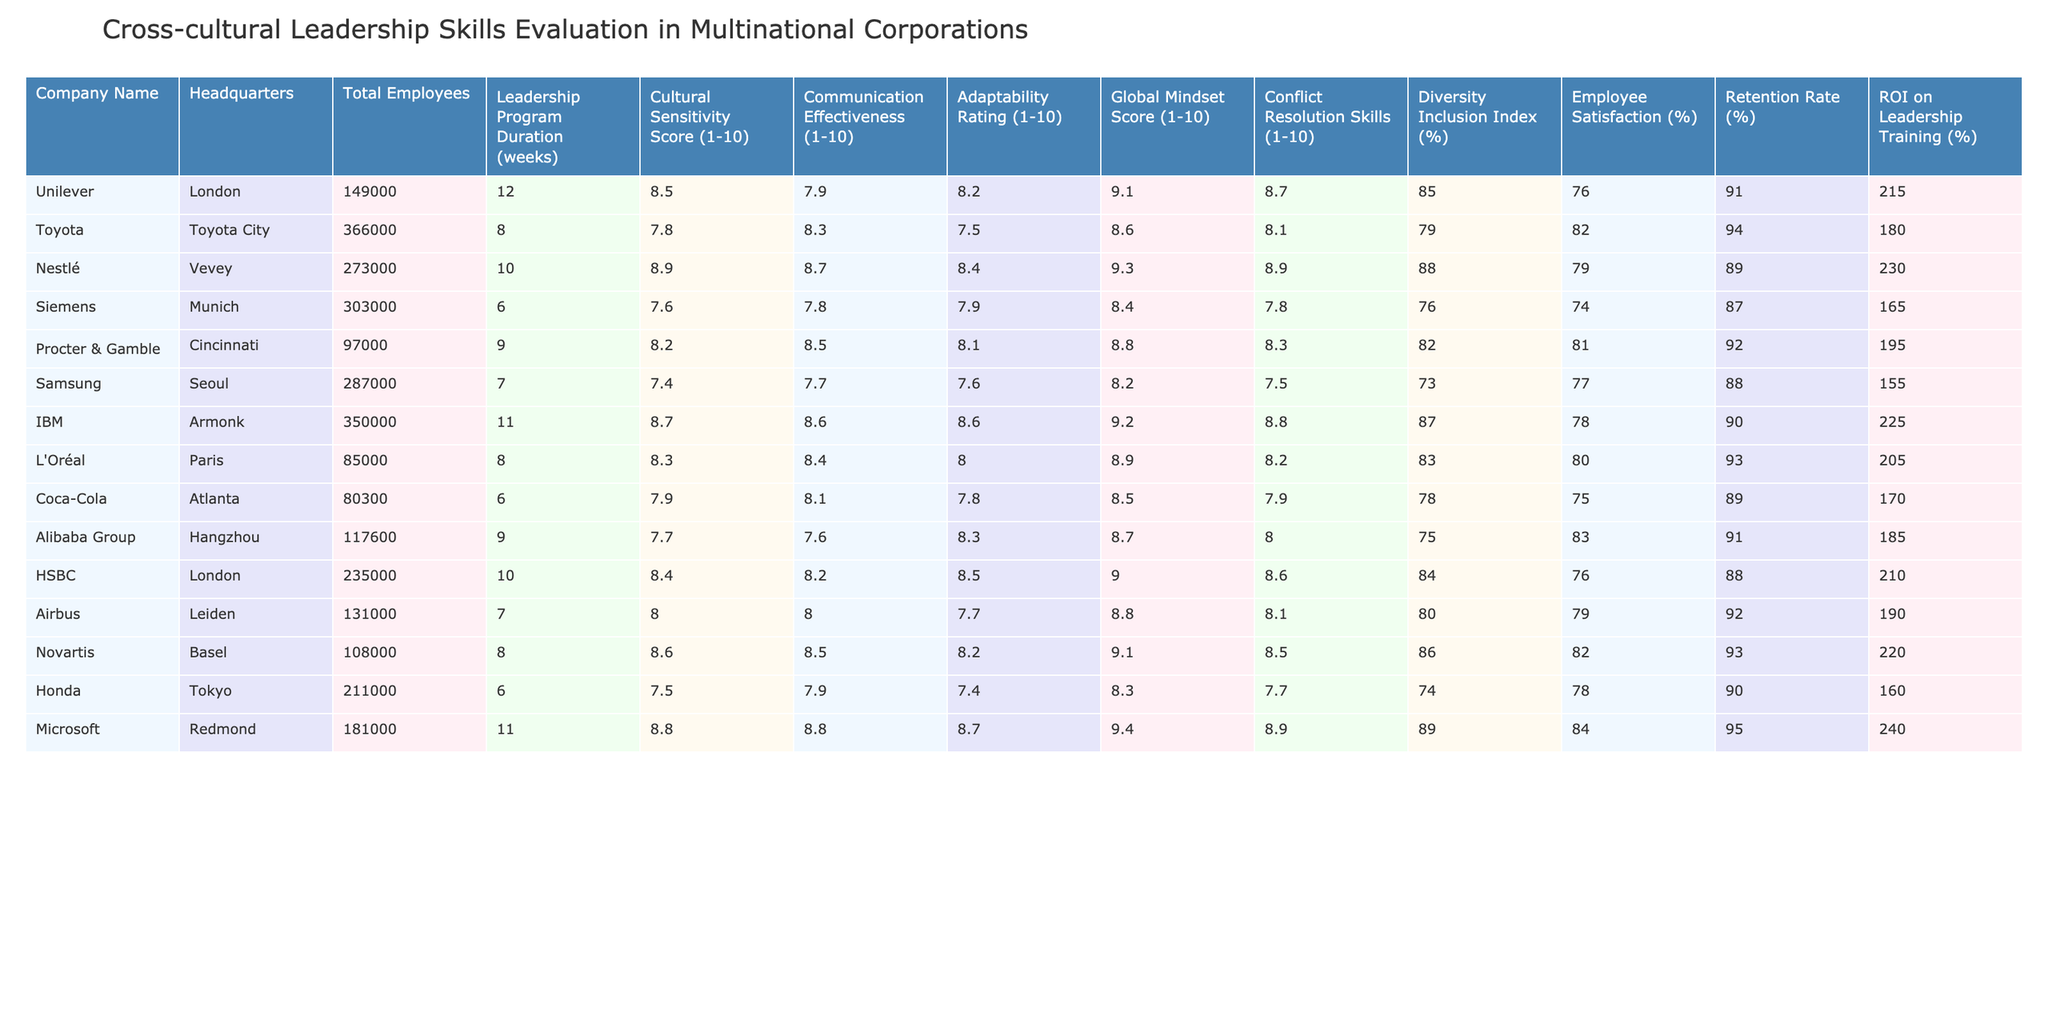What is the Cultural Sensitivity Score for Toyota? The Cultural Sensitivity Score for Toyota is located in the row corresponding to Toyota. Referring to the table, it reads 7.8.
Answer: 7.8 Which company has the highest Diversity Inclusion Index? To find the highest Diversity Inclusion Index, I look through the table and identify the values. The highest value is 88% for Nestlé.
Answer: 88% What is the average Retention Rate for the companies listed? First, I sum the Retention Rates of all companies: (91 + 94 + 89 + 87 + 92 + 88 + 90 + 93 + 90 + 95) = 909. There are 10 companies, so the average Retention Rate is 909/10 = 90.9%.
Answer: 90.9% Does Samsung have a higher Adaptability Rating than Toyota? Comparing the Adaptability Ratings in the table, Samsung has a rating of 7.6 and Toyota has a rating of 7.5. Since 7.6 is greater than 7.5, the statement is true.
Answer: Yes What is the total ROI on Leadership Training for IBM and Microsoft combined? The ROI on Leadership Training for IBM is 225% and for Microsoft, it is 240%. Adding them gives: 225 + 240 = 465%.
Answer: 465% Which company has the longest Leadership Program duration, and what is that duration? Looking at the Leadership Program Duration column, the maximum value is 12 weeks for Unilever. Therefore, Unilever has the longest program duration.
Answer: Unilever, 12 weeks Is the Employee Satisfaction percentage for Procter & Gamble higher than that for Coca-Cola? Procter & Gamble has an Employee Satisfaction percentage of 81%, while Coca-Cola has 75%. Since 81% is greater than 75%, the answer is yes.
Answer: Yes What is the difference in Global Mindset Scores between Nestlé and Siemens? Nestlé has a Global Mindset Score of 9.3, while Siemens has a score of 8.4. To find the difference: 9.3 - 8.4 = 0.9.
Answer: 0.9 What is the average Cultural Sensitivity Score across all companies? I calculate the average by summing the Cultural Sensitivity Scores: (8.5 + 7.8 + 8.9 + 7.6 + 8.2 + 7.4 + 8.7 + 8.3 + 7.7 + 8.4 + 8.6 + 7.5 + 8.8) = 103.8. Then, I divide by the number of companies, which is 13: 103.8 / 13 = 7.98.
Answer: 7.98 Are the Communication Effectiveness scores for IBM and Microsoft the same? IBM has a Communication Effectiveness score of 8.6, and Microsoft has a score of 8.8. Since the scores are different, the answer is no.
Answer: No 